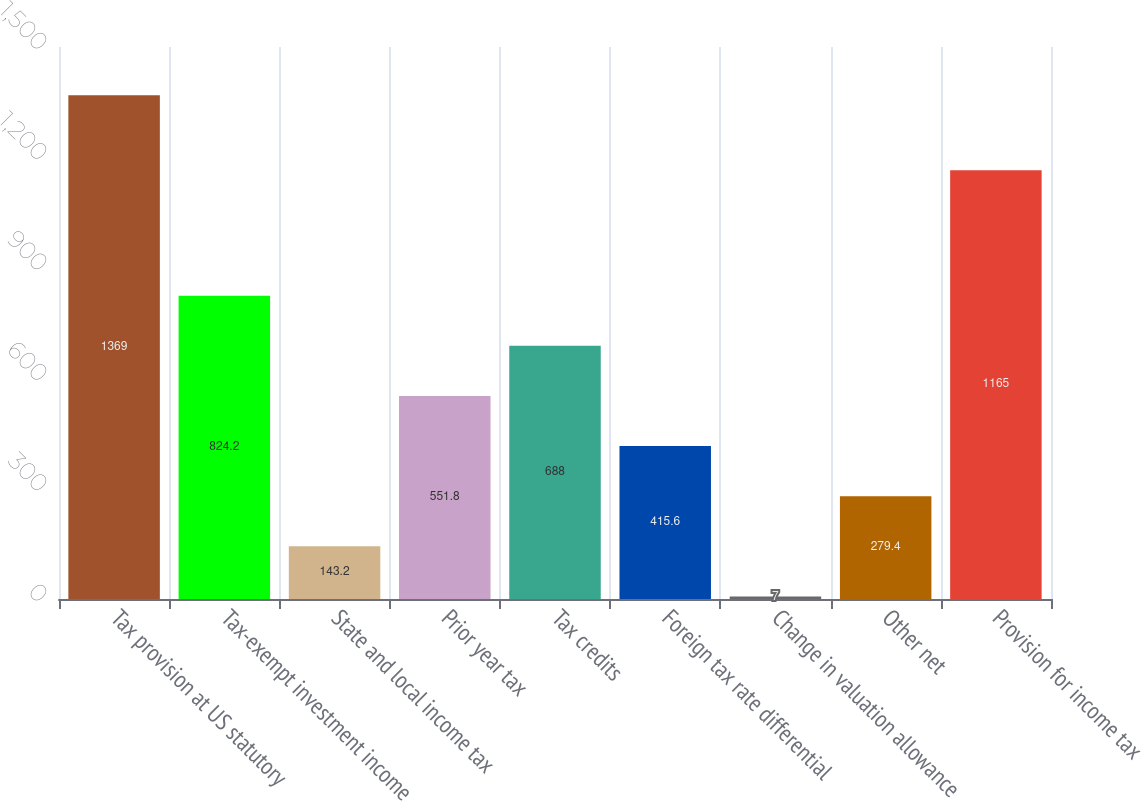Convert chart. <chart><loc_0><loc_0><loc_500><loc_500><bar_chart><fcel>Tax provision at US statutory<fcel>Tax-exempt investment income<fcel>State and local income tax<fcel>Prior year tax<fcel>Tax credits<fcel>Foreign tax rate differential<fcel>Change in valuation allowance<fcel>Other net<fcel>Provision for income tax<nl><fcel>1369<fcel>824.2<fcel>143.2<fcel>551.8<fcel>688<fcel>415.6<fcel>7<fcel>279.4<fcel>1165<nl></chart> 